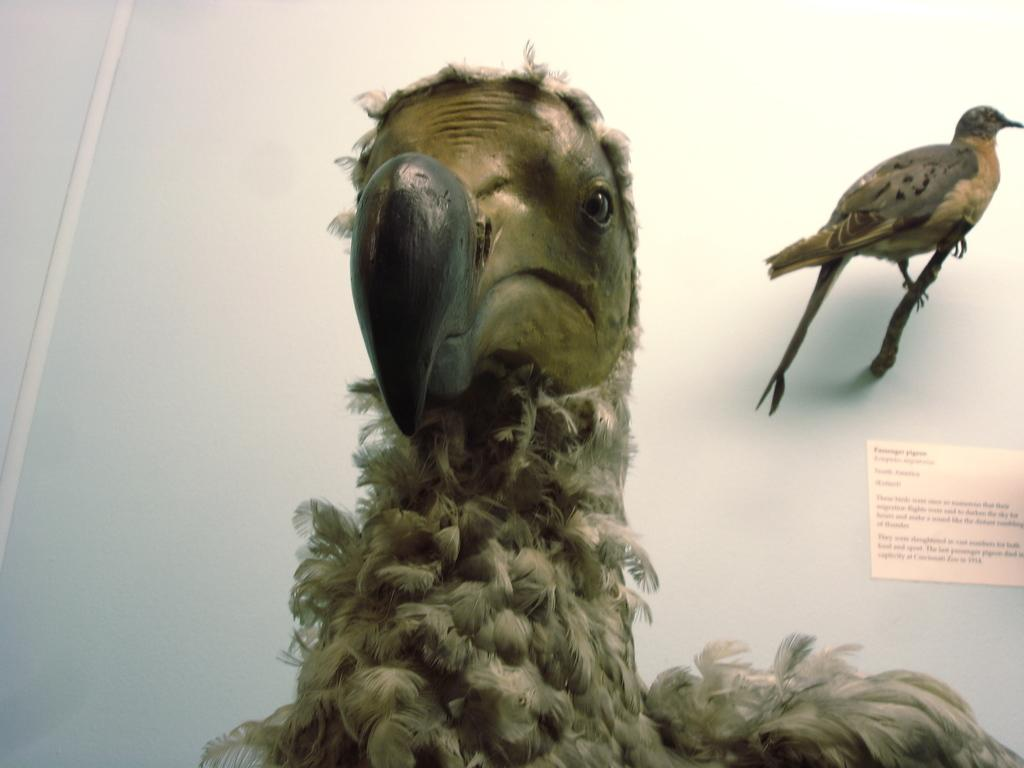What type of animals can be seen in the image? There are birds in the image. What is visible in the background of the image? There is a wall in the background of the image. What is attached to the wall in the image? There is a paper pasted on the wall. How many fingers can be seen in the image? There are no fingers visible in the image. What type of nest can be seen in the image? There is no nest present in the image; it features birds and a wall with a paper pasted on it. 